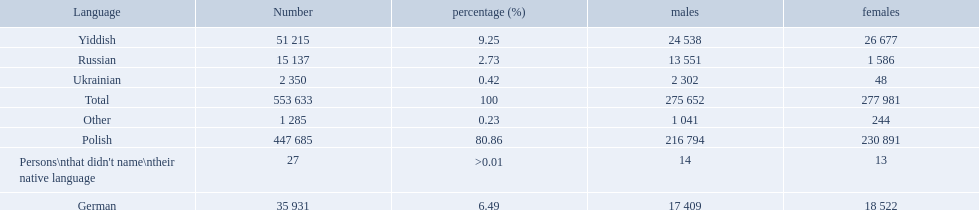What was the least spoken language Ukrainian. What was the most spoken? Polish. How many speakers are represented in polish? 447 685. How many represented speakers are yiddish? 51 215. What is the total number of speakers? 553 633. 